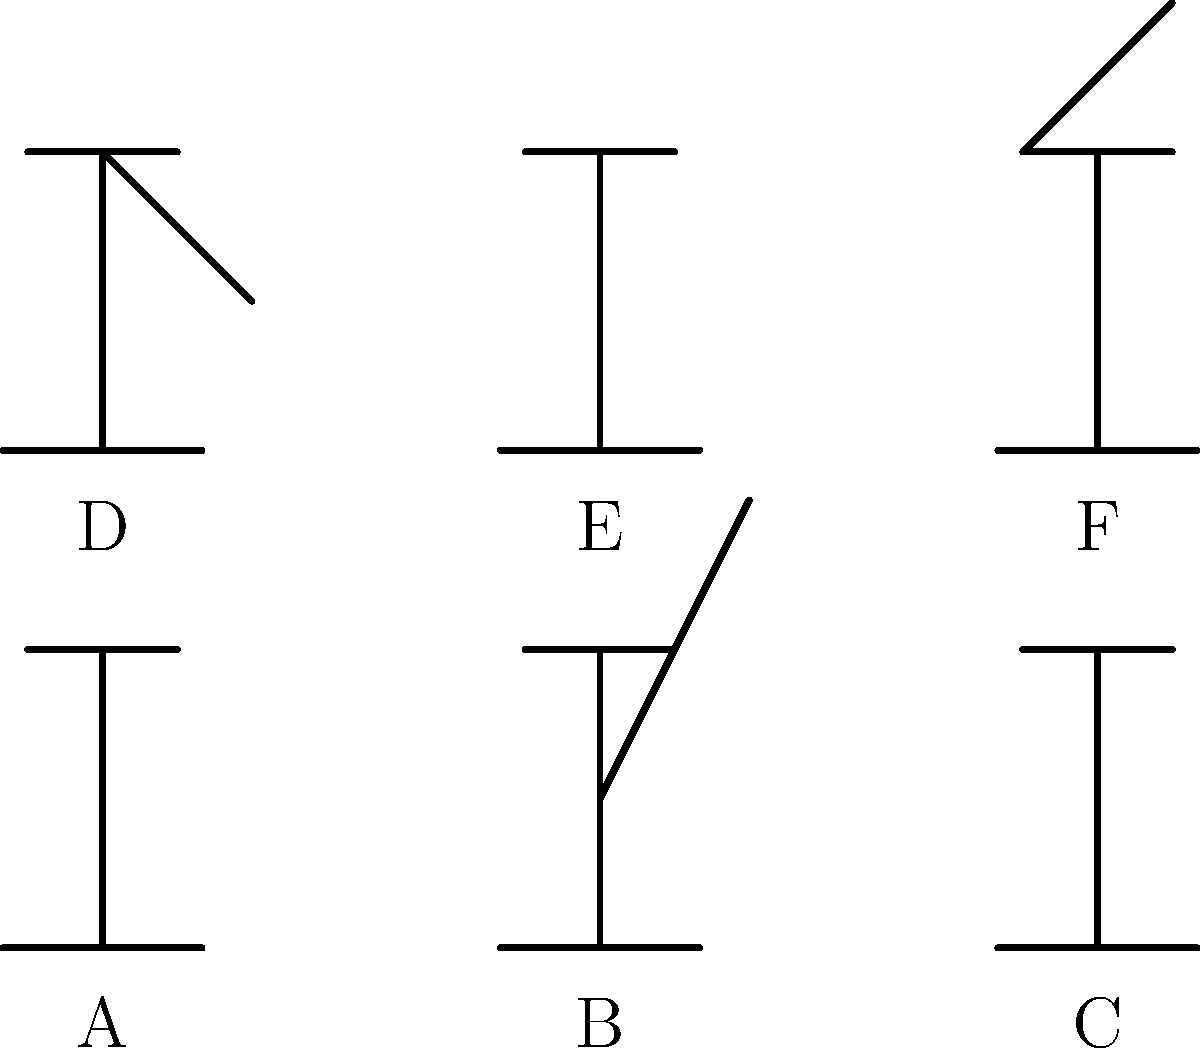As a public health officer supporting traditional midwives, which of the birthing positions illustrated above (A-F) are generally considered safe and recommended for uncomplicated deliveries? Select all that apply. To answer this question, we need to analyze each position from a safety and physiological perspective:

1. Position A: Upright sitting position. This is generally safe and can help with gravity and pelvic opening.

2. Position B: Semi-reclined position. This is also considered safe and can provide good support for the mother.

3. Position C: Fully reclined position. While common in hospitals, this position is not ideal for natural birth as it works against gravity and can slow labor.

4. Position D: Squatting position. This is an excellent position for birth as it widens the pelvic outlet and uses gravity to assist.

5. Position E: Hands and knees position. This position can help relieve back pain and assist with fetal rotation.

6. Position F: Standing position. While not ideal for the actual birth, this can be beneficial during labor to encourage fetal descent.

Positions A, B, D, and E are generally considered safe and recommended for uncomplicated deliveries. They allow for gravity to assist, provide good pelvic opening, and can be easily supported by midwives.

Position C is less ideal as it can slow labor and increase the risk of interventions.

Position F is good for labor but not typically used for the actual birth due to the risk of the baby falling.
Answer: A, B, D, E 